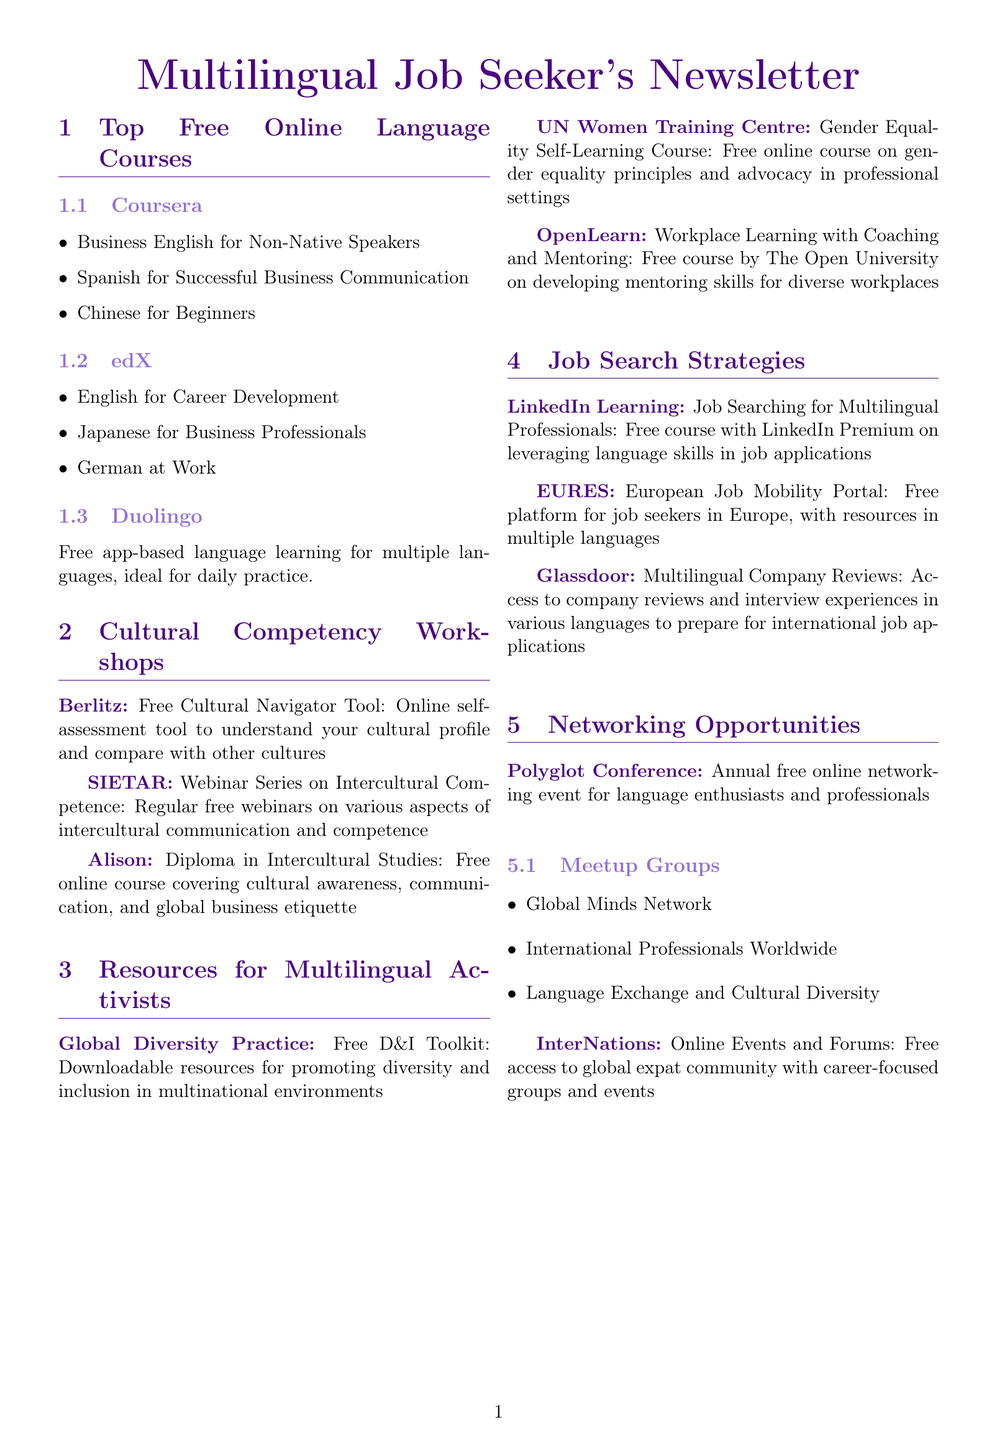What workshop does Berlitz offer? Berlitz offers a Free Cultural Navigator Tool, which is an online self-assessment tool.
Answer: Free Cultural Navigator Tool How many courses does edX provide in this newsletter? The edX section lists three courses for job seekers.
Answer: three What is the name of the online platform for job seekers in Europe? The document mentions the European Job Mobility Portal for job seekers.
Answer: European Job Mobility Portal Which organization provides a Gender Equality Self-Learning Course? The UN Women Training Centre is the organization that offers the Gender Equality Self-Learning Course.
Answer: UN Women Training Centre What is the focus of the Diploma in Intercultural Studies course? This course covers cultural awareness, communication, and global business etiquette.
Answer: cultural awareness, communication, and global business etiquette Which platform offers a course specifically for multilingual professionals? LinkedIn Learning provides a course for multilingual professionals.
Answer: LinkedIn Learning How often does SIETAR host webinars? SIETAR hosts regular free webinars as part of their series, but a specific frequency is not mentioned.
Answer: regular What event is described as an annual online networking event? The Polyglot Conference is described as an annual online networking event for language enthusiasts.
Answer: Polyglot Conference What free app-based language learning tool is mentioned? The document mentions Duolingo as a free app-based language learning tool.
Answer: Duolingo 